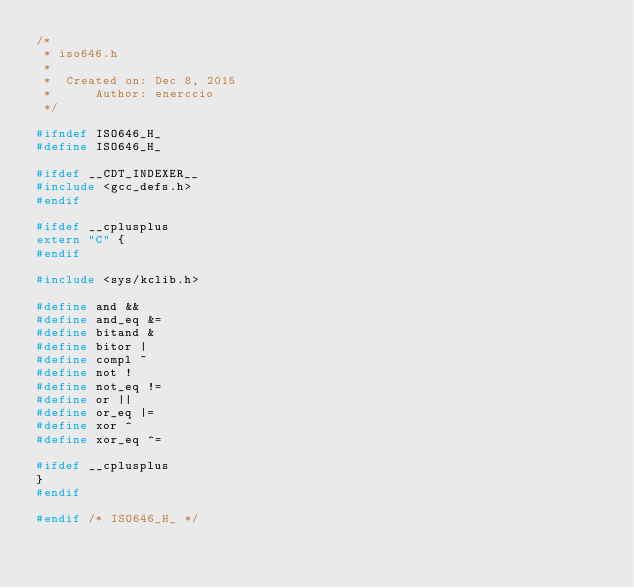<code> <loc_0><loc_0><loc_500><loc_500><_C_>/*
 * iso646.h
 *
 *  Created on: Dec 8, 2015
 *      Author: enerccio
 */

#ifndef ISO646_H_
#define ISO646_H_

#ifdef __CDT_INDEXER__
#include <gcc_defs.h>
#endif

#ifdef __cplusplus
extern "C" {
#endif

#include <sys/kclib.h>

#define and &&
#define and_eq &=
#define bitand &
#define bitor |
#define compl ~
#define not !
#define not_eq !=
#define or ||
#define or_eq |=
#define xor ^
#define xor_eq ^=

#ifdef __cplusplus
}
#endif

#endif /* ISO646_H_ */
</code> 